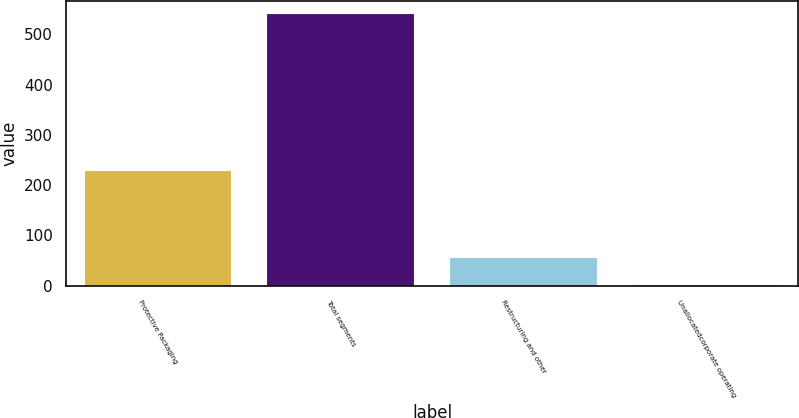Convert chart to OTSL. <chart><loc_0><loc_0><loc_500><loc_500><bar_chart><fcel>Protective Packaging<fcel>Total segments<fcel>Restructuring and other<fcel>Unallocatedcorporate operating<nl><fcel>228.7<fcel>539.7<fcel>54.6<fcel>0.7<nl></chart> 